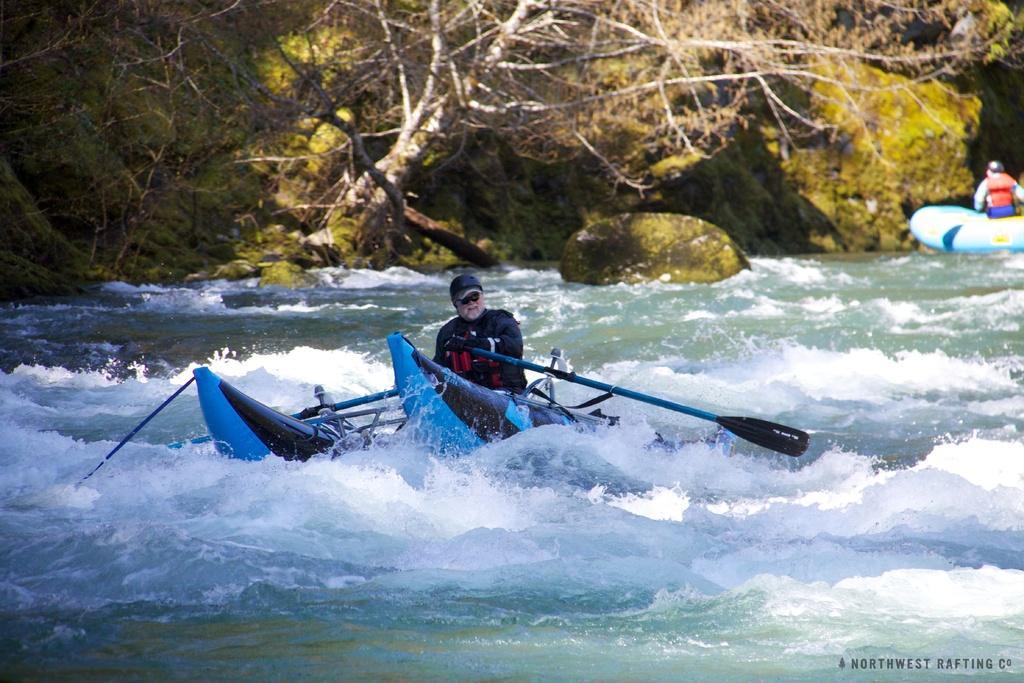How would you summarize this image in a sentence or two? In this image, in the middle there is a man on the boat. At the bottom there are waves, water and a text. In the background there is a man, boat, stones and trees. 